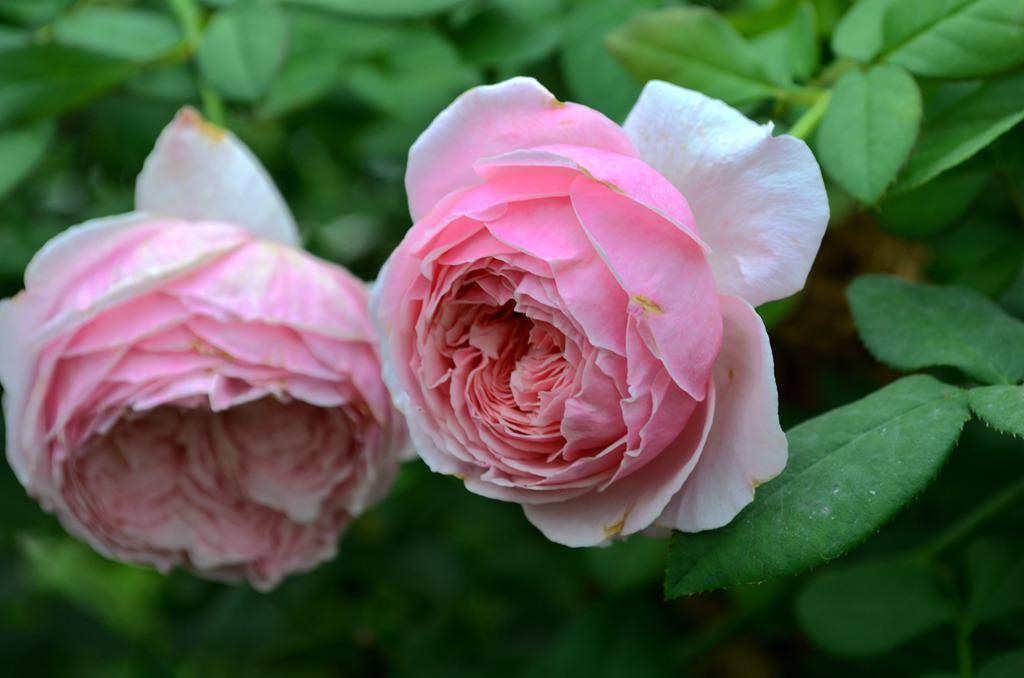What is present in the image? There is a plant in the image. What type of flowers are on the plant? The plant has two pink roses. What type of building is being constructed by the carpenter in the image? There is no carpenter or building present in the image; it only features a plant with pink roses. 